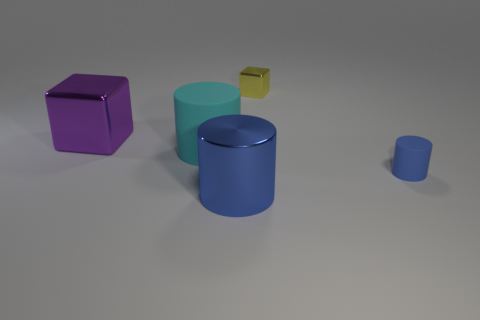What shape is the metallic object that is right of the big rubber object and behind the large blue cylinder?
Ensure brevity in your answer.  Cube. Does the blue object to the left of the tiny yellow metallic cube have the same shape as the rubber thing that is left of the yellow block?
Make the answer very short. Yes. How many objects are either cylinders that are in front of the big cyan cylinder or tiny yellow objects?
Your answer should be very brief. 3. There is a object that is the same color as the tiny cylinder; what is its material?
Ensure brevity in your answer.  Metal. There is a metallic block that is on the left side of the blue thing that is in front of the small rubber cylinder; are there any blocks that are behind it?
Your answer should be very brief. Yes. Are there fewer cyan matte cylinders left of the cyan rubber object than purple metallic objects left of the purple shiny thing?
Give a very brief answer. No. There is a large cylinder that is made of the same material as the big block; what is its color?
Your response must be concise. Blue. There is a block in front of the cube that is behind the purple cube; what is its color?
Keep it short and to the point. Purple. Are there any big shiny things that have the same color as the big rubber thing?
Your answer should be very brief. No. There is a thing that is the same size as the blue matte cylinder; what shape is it?
Your answer should be compact. Cube. 